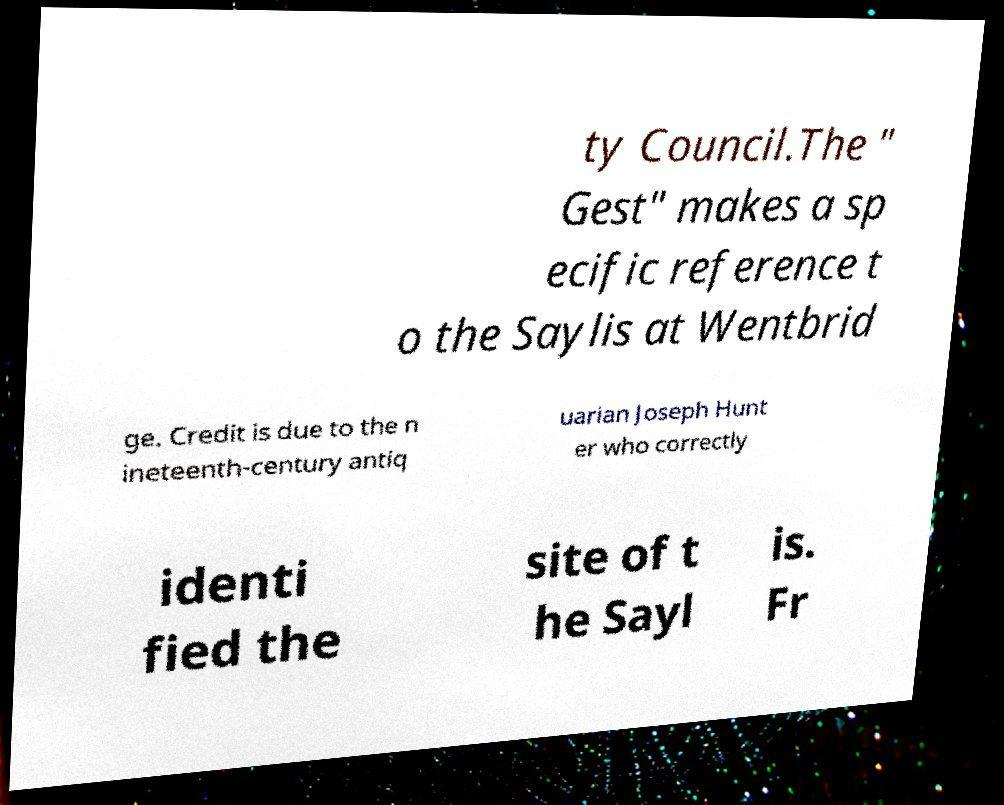I need the written content from this picture converted into text. Can you do that? ty Council.The " Gest" makes a sp ecific reference t o the Saylis at Wentbrid ge. Credit is due to the n ineteenth-century antiq uarian Joseph Hunt er who correctly identi fied the site of t he Sayl is. Fr 